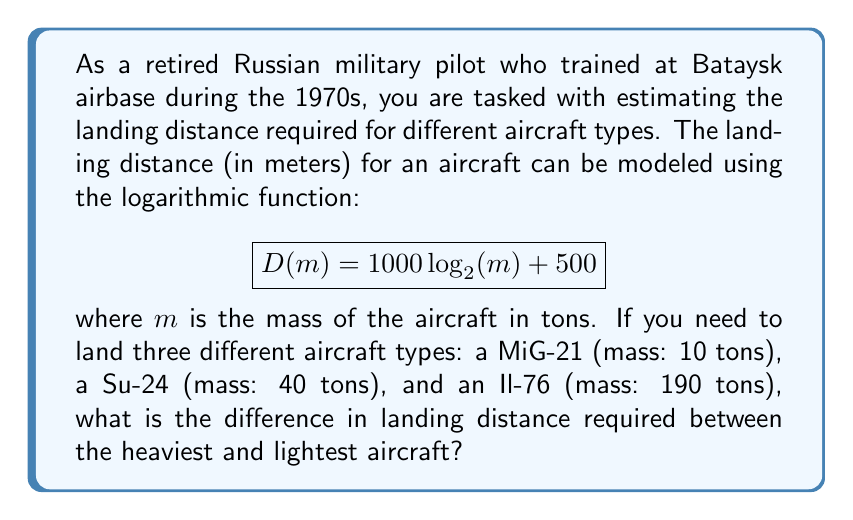Show me your answer to this math problem. To solve this problem, we need to follow these steps:

1. Calculate the landing distance for each aircraft using the given function.
2. Identify the heaviest and lightest aircraft.
3. Calculate the difference in landing distance between the heaviest and lightest aircraft.

Let's start with step 1:

For MiG-21 (10 tons):
$$D(10) = 1000 \log_{2}(10) + 500 = 1000 \cdot 3.32 + 500 = 3820 \text{ meters}$$

For Su-24 (40 tons):
$$D(40) = 1000 \log_{2}(40) + 500 = 1000 \cdot 5.32 + 500 = 5820 \text{ meters}$$

For Il-76 (190 tons):
$$D(190) = 1000 \log_{2}(190) + 500 = 1000 \cdot 7.57 + 500 = 8070 \text{ meters}$$

Step 2: The heaviest aircraft is the Il-76 (190 tons), and the lightest is the MiG-21 (10 tons).

Step 3: Calculate the difference in landing distance:
$$8070 \text{ meters} - 3820 \text{ meters} = 4250 \text{ meters}$$

Therefore, the difference in landing distance required between the heaviest (Il-76) and lightest (MiG-21) aircraft is 4250 meters.
Answer: 4250 meters 